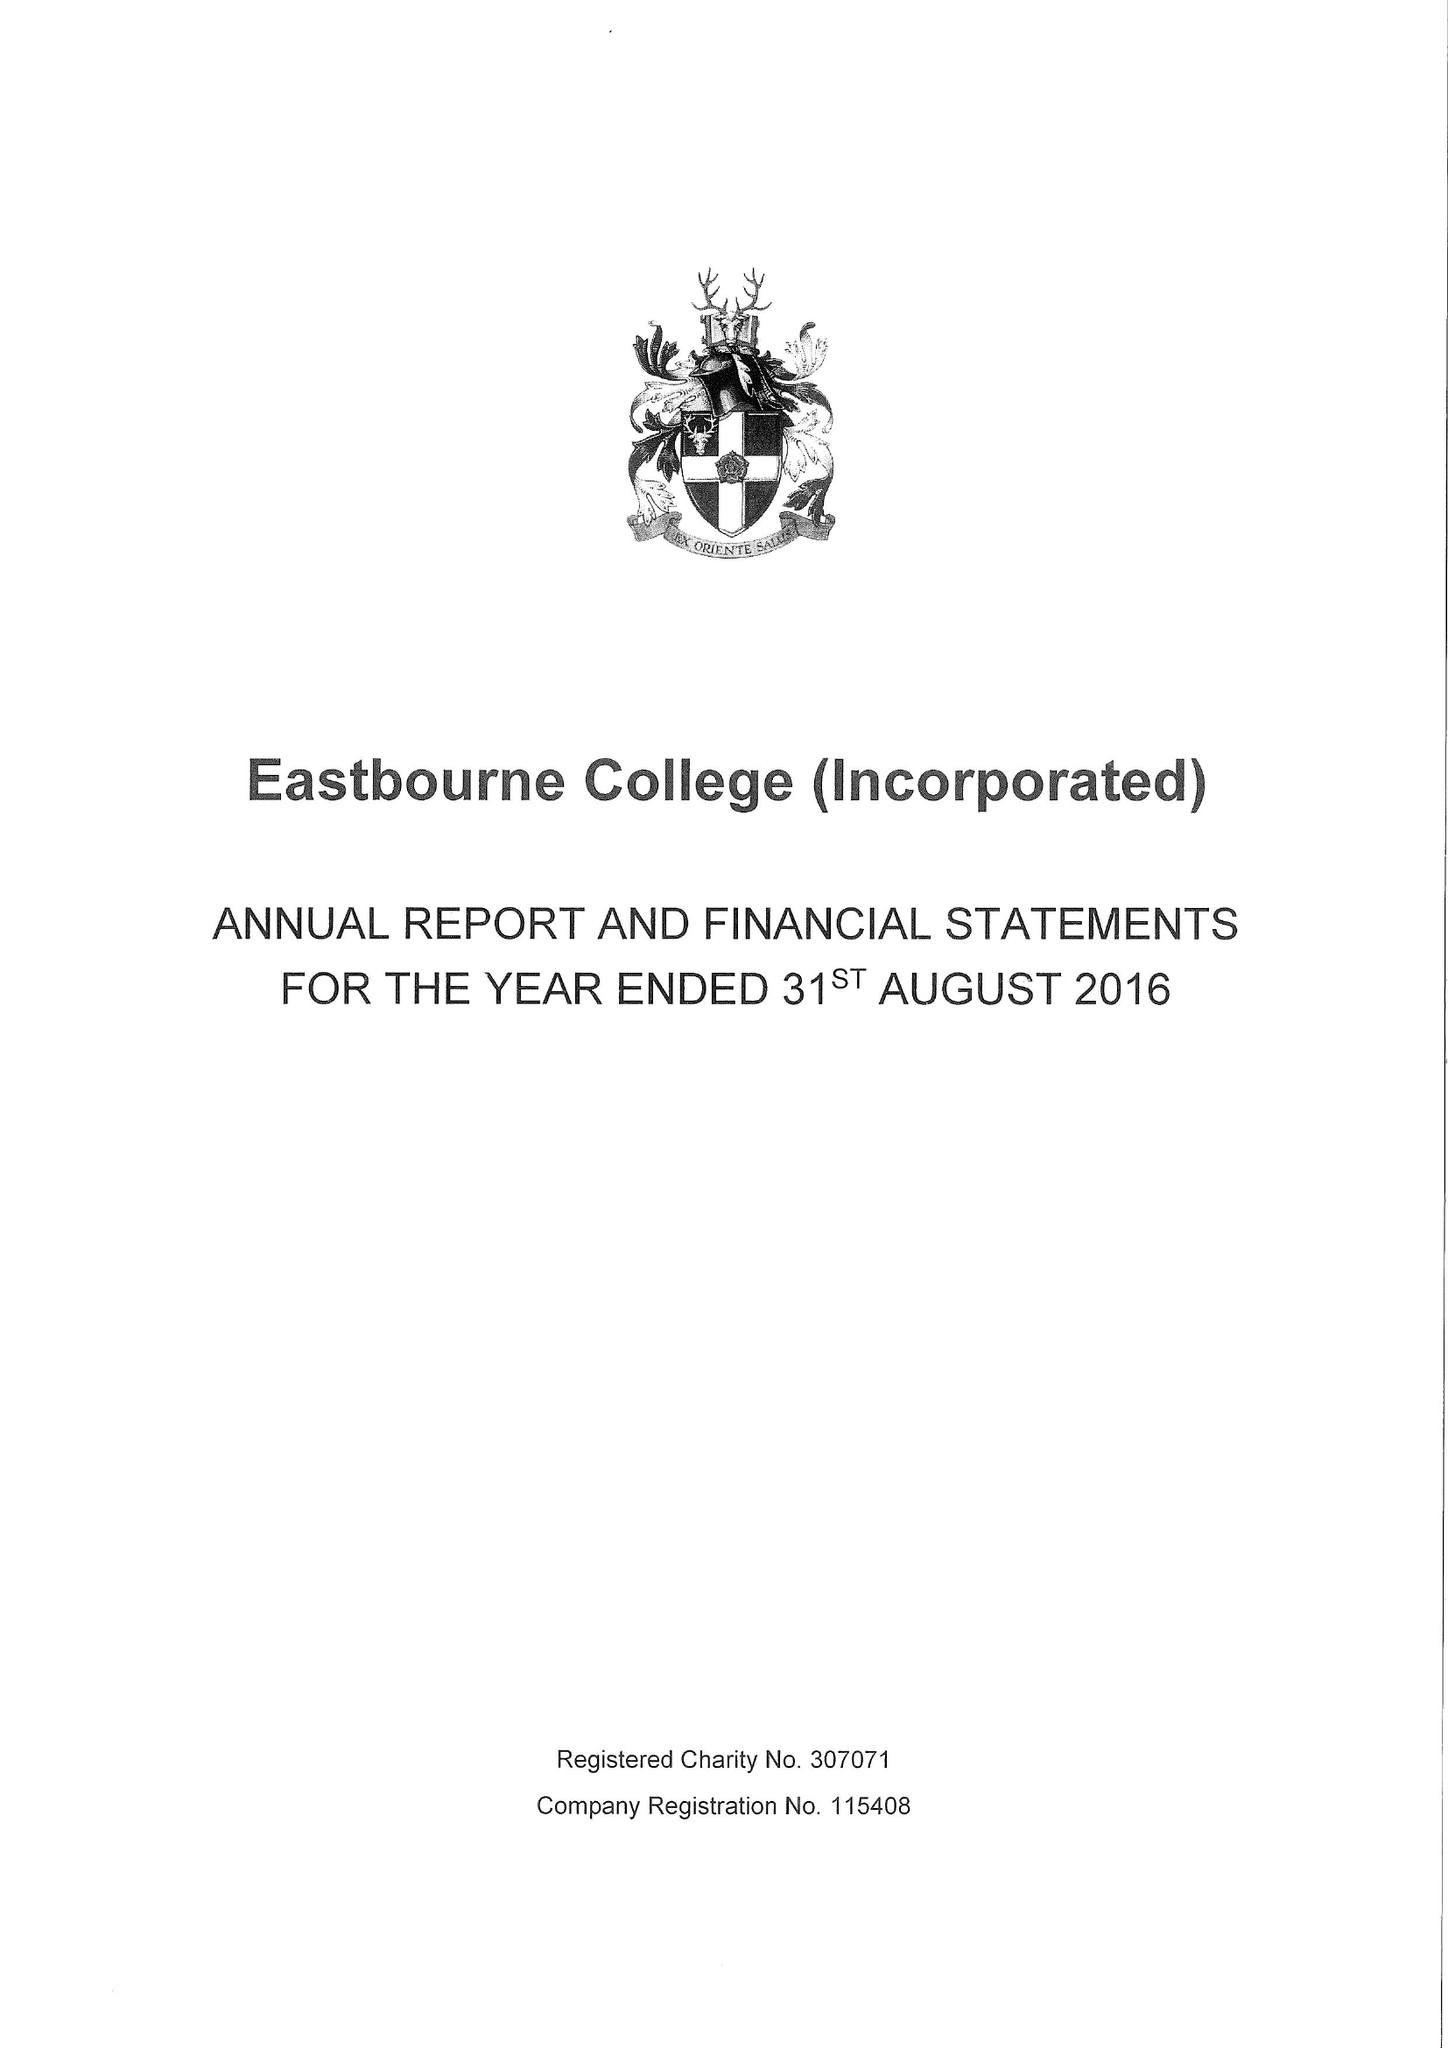What is the value for the address__post_town?
Answer the question using a single word or phrase. EASTBOURNE 